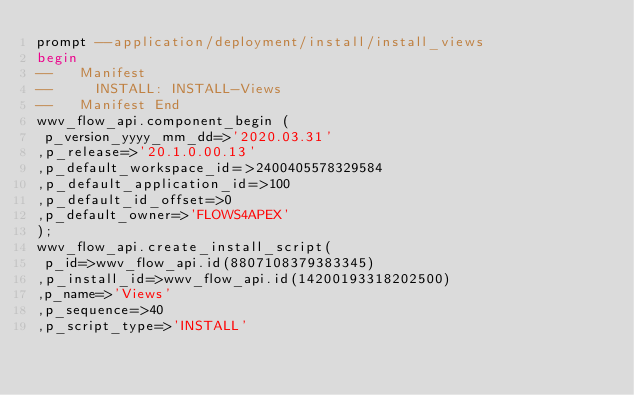Convert code to text. <code><loc_0><loc_0><loc_500><loc_500><_SQL_>prompt --application/deployment/install/install_views
begin
--   Manifest
--     INSTALL: INSTALL-Views
--   Manifest End
wwv_flow_api.component_begin (
 p_version_yyyy_mm_dd=>'2020.03.31'
,p_release=>'20.1.0.00.13'
,p_default_workspace_id=>2400405578329584
,p_default_application_id=>100
,p_default_id_offset=>0
,p_default_owner=>'FLOWS4APEX'
);
wwv_flow_api.create_install_script(
 p_id=>wwv_flow_api.id(8807108379383345)
,p_install_id=>wwv_flow_api.id(14200193318202500)
,p_name=>'Views'
,p_sequence=>40
,p_script_type=>'INSTALL'</code> 